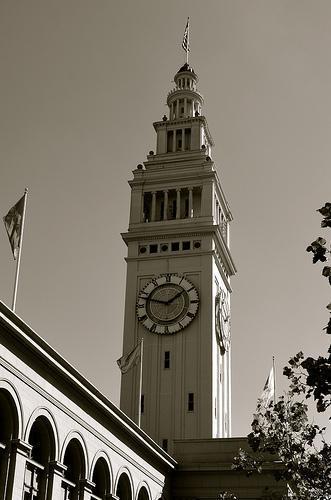How many flags in the photo?
Give a very brief answer. 4. How many clock hands are pointed at the numural 2?
Give a very brief answer. 1. 